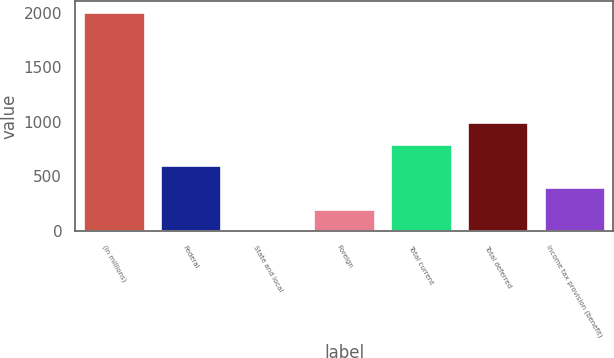Convert chart. <chart><loc_0><loc_0><loc_500><loc_500><bar_chart><fcel>(In millions)<fcel>Federal<fcel>State and local<fcel>Foreign<fcel>Total current<fcel>Total deferred<fcel>Income tax provision (benefit)<nl><fcel>2005<fcel>602.06<fcel>0.8<fcel>201.22<fcel>802.48<fcel>1002.9<fcel>401.64<nl></chart> 